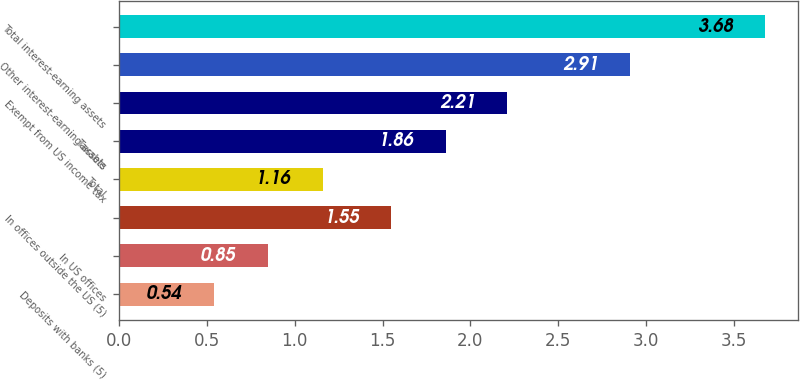Convert chart to OTSL. <chart><loc_0><loc_0><loc_500><loc_500><bar_chart><fcel>Deposits with banks (5)<fcel>In US offices<fcel>In offices outside the US (5)<fcel>Total<fcel>Taxable<fcel>Exempt from US income tax<fcel>Other interest-earning assets<fcel>Total interest-earning assets<nl><fcel>0.54<fcel>0.85<fcel>1.55<fcel>1.16<fcel>1.86<fcel>2.21<fcel>2.91<fcel>3.68<nl></chart> 